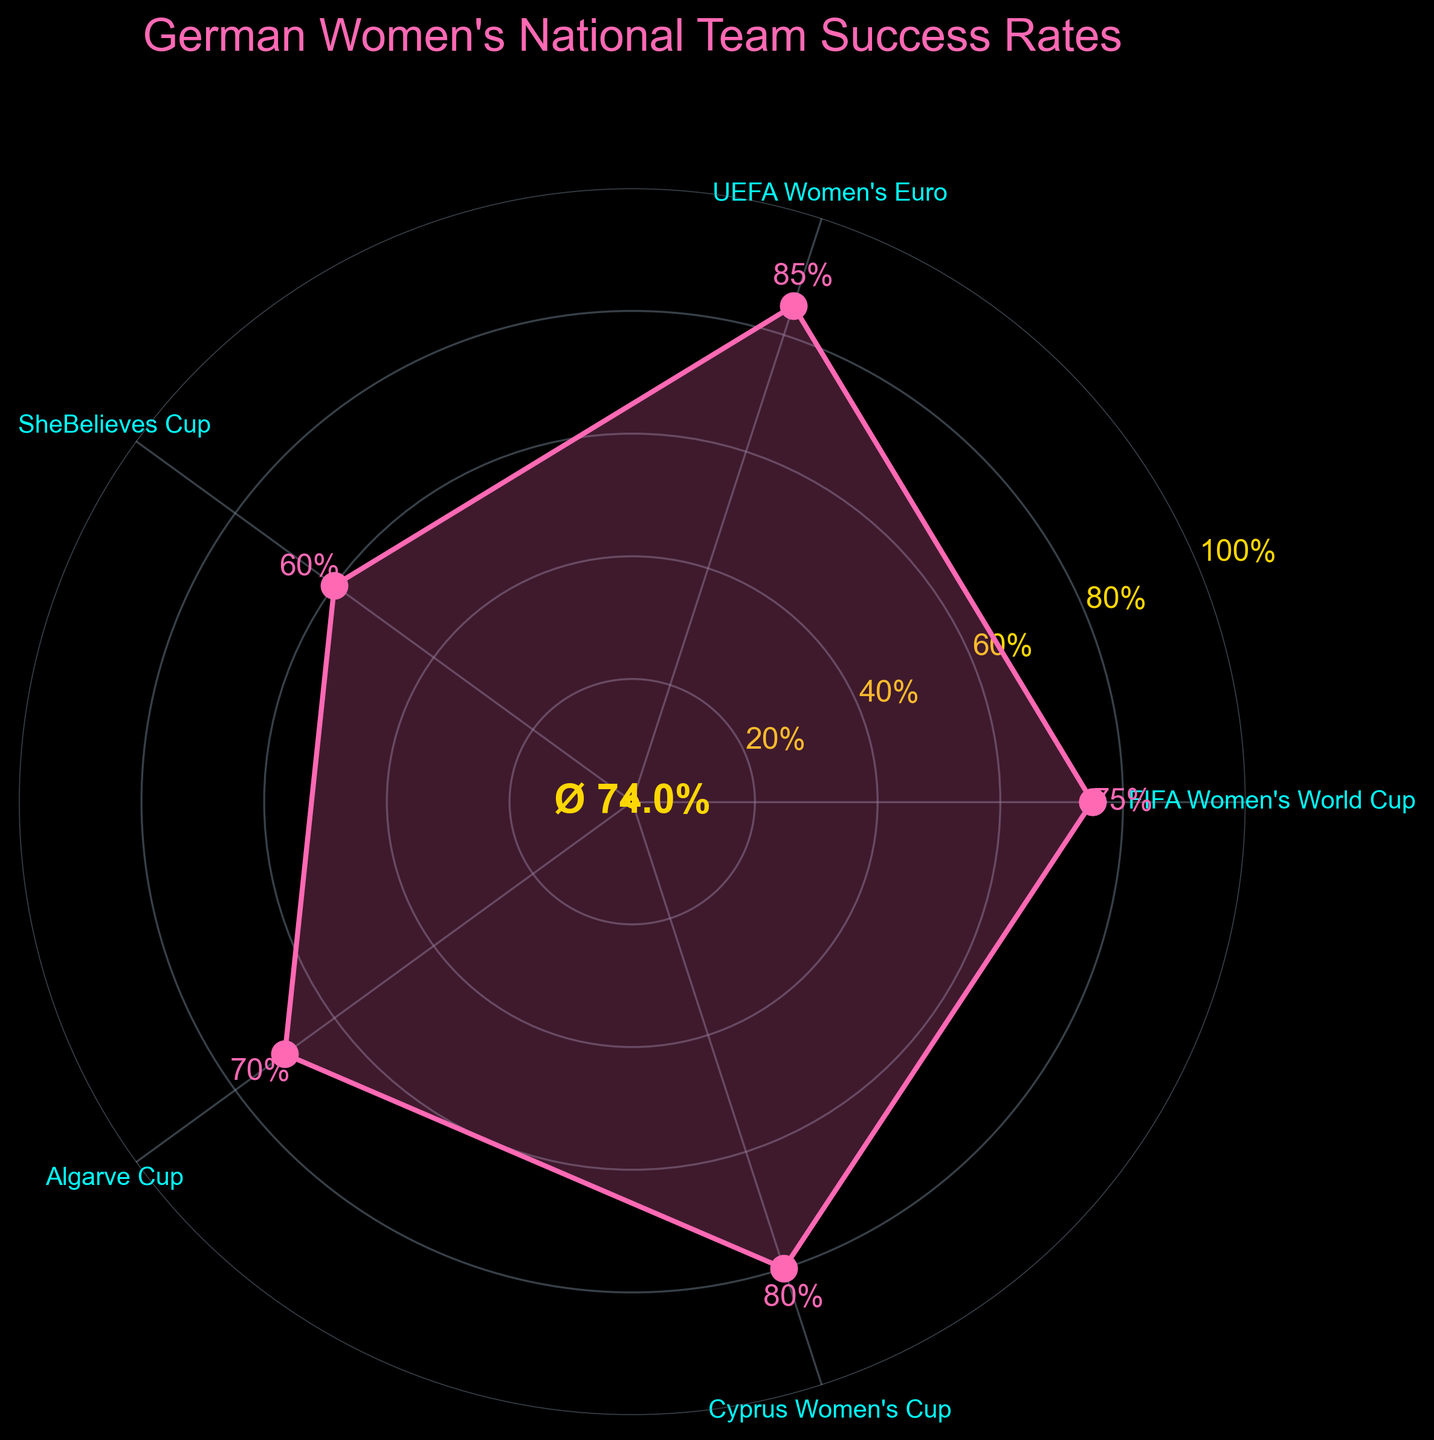What is the success rate of the German women's national team in the UEFA Women's Euro? The success rate in the UEFA Women's Euro can be directly read from the figure where the labels are placed around the circle. The label "UEFA Women's Euro" has a success rate of 85%.
Answer: 85% Which tournament has the lowest success rate? To identify the lowest success rate, compare the numerical values of the success rates associated with each tournament label. The lowest success rate is found with the "SheBelieves Cup" at 60%.
Answer: SheBelieves Cup What is the average success rate across all tournaments? The average success rate can be calculated by summing up the success rates of all tournaments and then dividing by the number of tournaments. The success rates are 75, 85, 60, 70, 80. The sum is 370, and there are 5 tournaments, so the average is 370/5.
Answer: 74% How does the success rate in the Cyprus Women's Cup compare to the success rate in the Algarve Cup? The success rate in the Cyprus Women's Cup is 80% and in the Algarve Cup is 70%. Thus, the Cyprus Women's Cup has a higher success rate.
Answer: Cyprus Women's Cup has a higher rate What is the median success rate among the tournaments? To find the median, organize the success rates in ascending order: 60, 70, 75, 80, 85. With an odd number of data points (5), the median is the middle value.
Answer: 75% Which tournament has a success rate closest to the average success rate? First, calculate the average success rate (74%). Then find the success rate that is numerically closest to this average. The success rates are 75, 85, 60, 70, and 80. The closest value to 74 is 75.
Answer: FIFA Women's World Cup What is the difference in success rate between the highest and the lowest tournaments? Identify the highest (85% at UEFA Women's Euro) and the lowest (60% at SheBelieves Cup) success rates, then subtract the lowest from the highest: 85% - 60% = 25%.
Answer: 25% How many tournaments have a success rate of 80% or higher? Count the tournaments with success rates equal to or greater than 80%, which are Cyprus Women's Cup (80%), FIFA Women's World Cup (75%), and UEFA Women's Euro (85%).
Answer: 3 